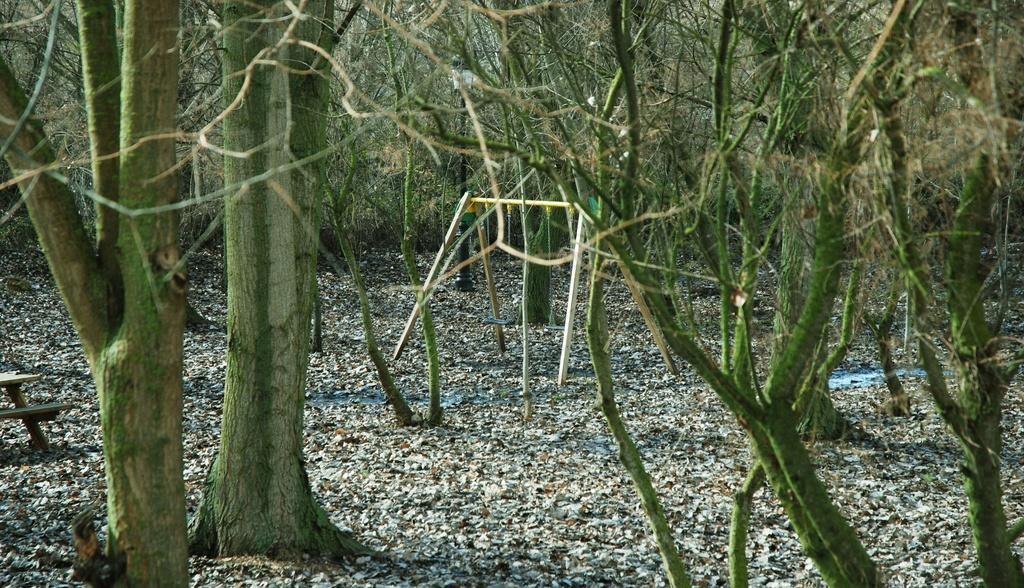What is the main object in the middle of the image? There is a pole in the middle of the image. What type of vegetation can be seen surrounding the pole? Trees are present in the image and are surrounding the pole. What adjustments does the manager make to the trees during the summer in the image? There is no manager or summer season mentioned in the image, and no adjustments are being made to the trees. 